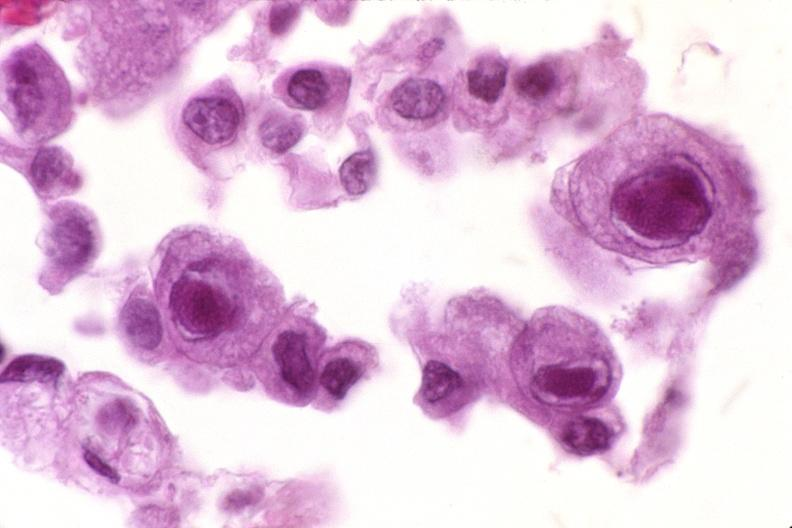s endometritis present?
Answer the question using a single word or phrase. No 